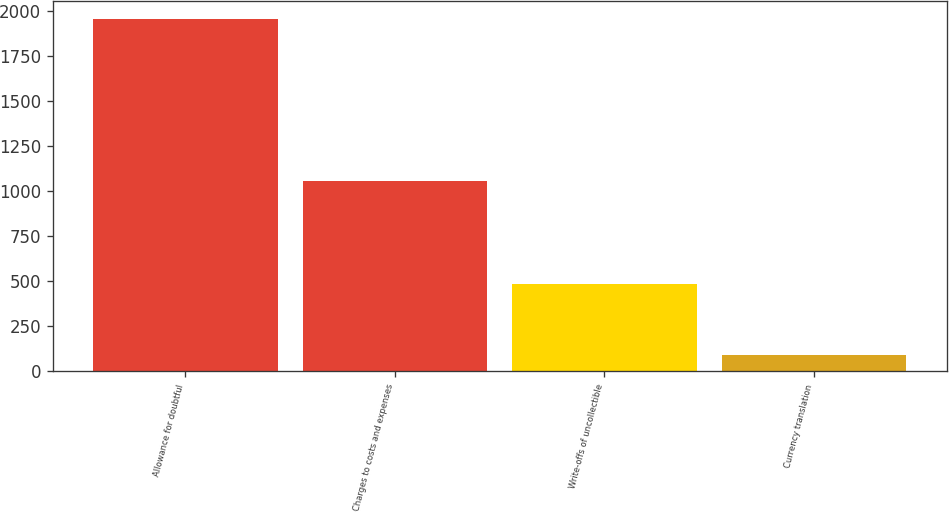<chart> <loc_0><loc_0><loc_500><loc_500><bar_chart><fcel>Allowance for doubtful<fcel>Charges to costs and expenses<fcel>Write-offs of uncollectible<fcel>Currency translation<nl><fcel>1957<fcel>1056<fcel>485<fcel>92<nl></chart> 